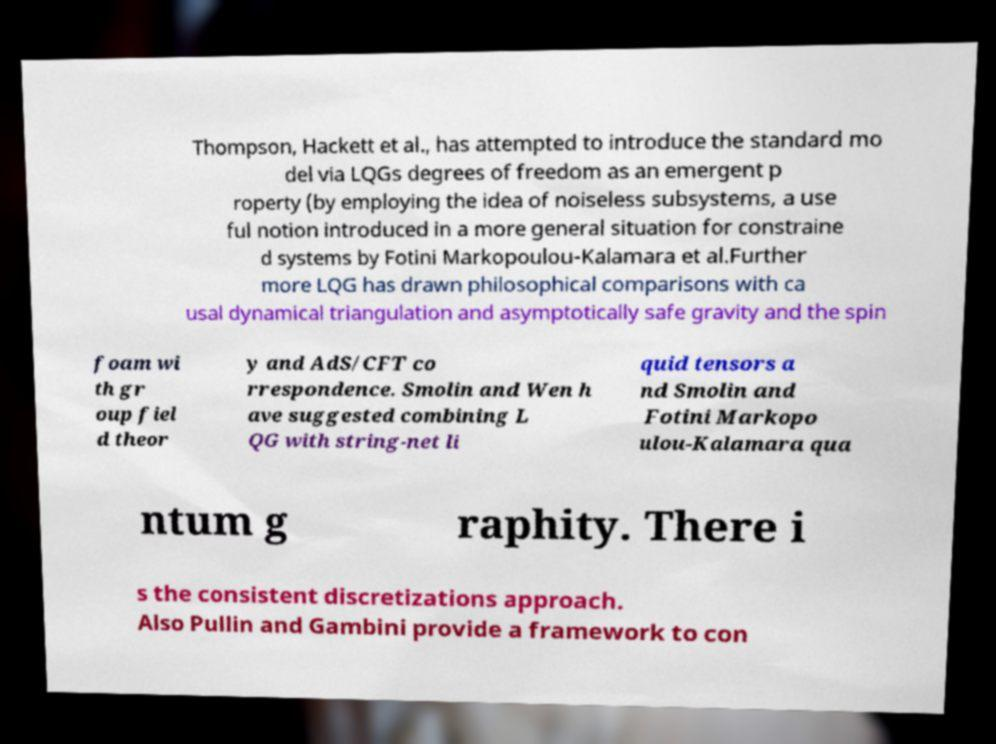Can you read and provide the text displayed in the image?This photo seems to have some interesting text. Can you extract and type it out for me? Thompson, Hackett et al., has attempted to introduce the standard mo del via LQGs degrees of freedom as an emergent p roperty (by employing the idea of noiseless subsystems, a use ful notion introduced in a more general situation for constraine d systems by Fotini Markopoulou-Kalamara et al.Further more LQG has drawn philosophical comparisons with ca usal dynamical triangulation and asymptotically safe gravity and the spin foam wi th gr oup fiel d theor y and AdS/CFT co rrespondence. Smolin and Wen h ave suggested combining L QG with string-net li quid tensors a nd Smolin and Fotini Markopo ulou-Kalamara qua ntum g raphity. There i s the consistent discretizations approach. Also Pullin and Gambini provide a framework to con 